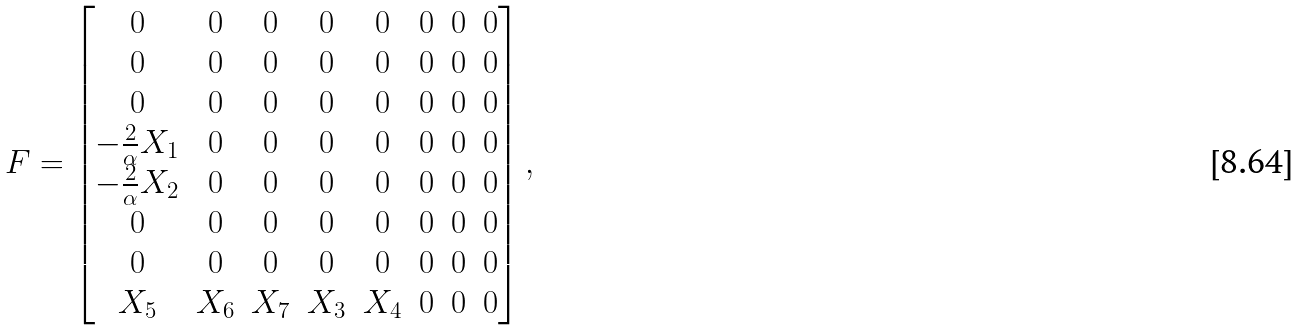<formula> <loc_0><loc_0><loc_500><loc_500>F = \begin{bmatrix} 0 & 0 & 0 & 0 & 0 & 0 & 0 & 0 \\ 0 & 0 & 0 & 0 & 0 & 0 & 0 & 0 \\ 0 & 0 & 0 & 0 & 0 & 0 & 0 & 0 \\ - \frac { 2 } { \alpha } X _ { 1 } & 0 & 0 & 0 & 0 & 0 & 0 & 0 \\ - \frac { 2 } { \alpha } X _ { 2 } & 0 & 0 & 0 & 0 & 0 & 0 & 0 \\ 0 & 0 & 0 & 0 & 0 & 0 & 0 & 0 \\ 0 & 0 & 0 & 0 & 0 & 0 & 0 & 0 \\ X _ { 5 } & X _ { 6 } & X _ { 7 } & X _ { 3 } & X _ { 4 } & 0 & 0 & 0 \end{bmatrix} ,</formula> 